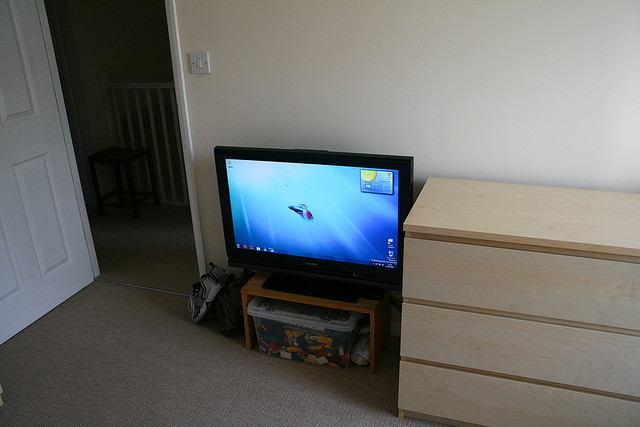What satellite provider is on the screen? Unfortunately, it's not possible to determine the satellite provider from the image alone as the screen does not display any distinguishable logos or service-specific interfaces. To identify the provider, one would typically look for any specific logos, the user interface design that may be unique to a provider, or might consider the type of remote control used, sometimes visible in a setting such as this. 